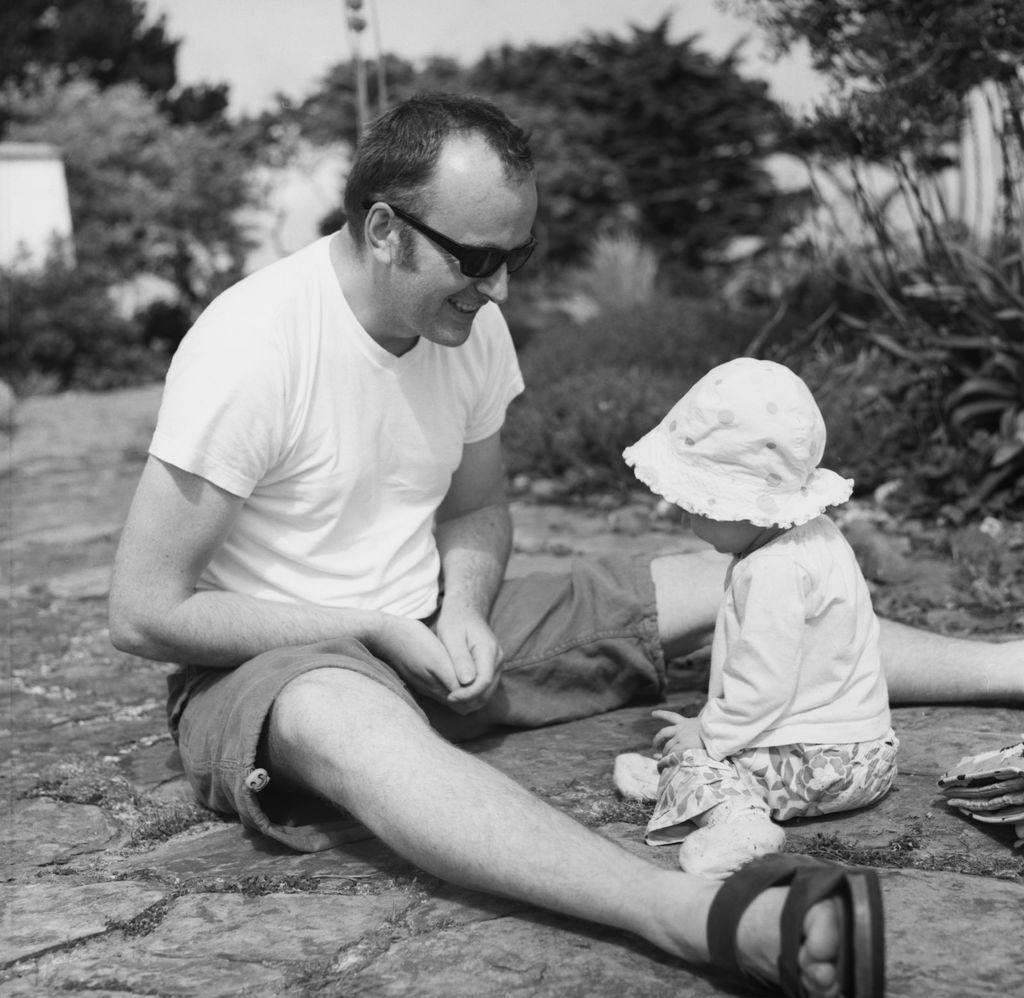Describe this image in one or two sentences. It is the black and white image in which there is a man sitting on the floor and playing with the kid who is in front of him. In the background there are trees. 